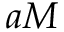Convert formula to latex. <formula><loc_0><loc_0><loc_500><loc_500>a M</formula> 